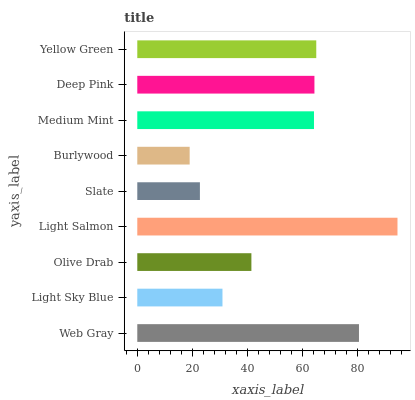Is Burlywood the minimum?
Answer yes or no. Yes. Is Light Salmon the maximum?
Answer yes or no. Yes. Is Light Sky Blue the minimum?
Answer yes or no. No. Is Light Sky Blue the maximum?
Answer yes or no. No. Is Web Gray greater than Light Sky Blue?
Answer yes or no. Yes. Is Light Sky Blue less than Web Gray?
Answer yes or no. Yes. Is Light Sky Blue greater than Web Gray?
Answer yes or no. No. Is Web Gray less than Light Sky Blue?
Answer yes or no. No. Is Medium Mint the high median?
Answer yes or no. Yes. Is Medium Mint the low median?
Answer yes or no. Yes. Is Light Salmon the high median?
Answer yes or no. No. Is Light Salmon the low median?
Answer yes or no. No. 